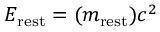Convert formula to latex. <formula><loc_0><loc_0><loc_500><loc_500>E _ { r e s t } = ( m _ { r e s t } ) c ^ { 2 }</formula> 